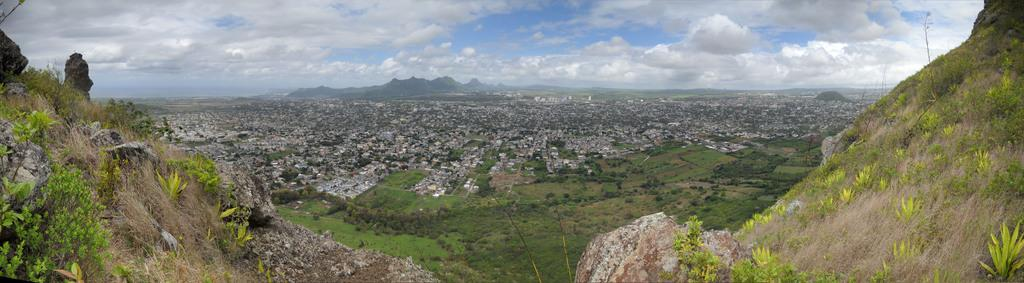What is located in the foreground of the image? There are mountains in the foreground of the image. What can be seen in the center of the image? There are buildings and greenery in the center of the image. What is visible in the background of the image? There are mountains and the sky in the background of the image. Can you tell me how many rods are used to measure the depth of the sand in the image? There is no sand or rod present in the image; it features mountains, buildings, greenery, and the sky. What type of weather can be seen in the image? The provided facts do not mention any specific weather conditions, so we cannot determine the weather from the image. 